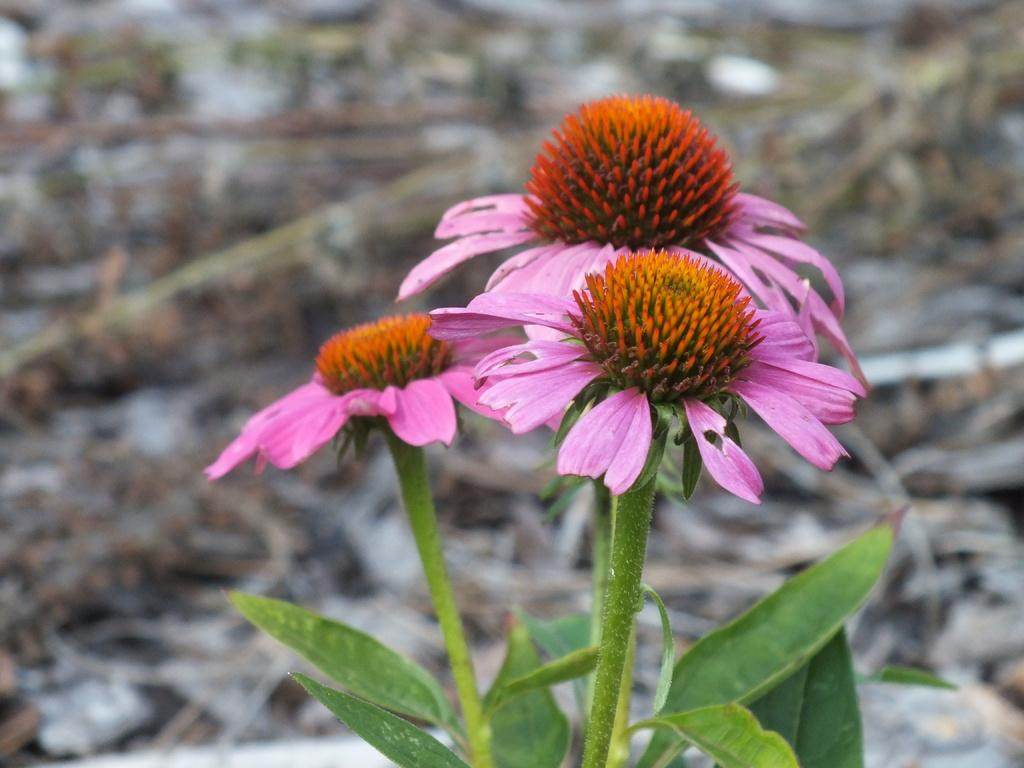What types of plants can be seen in the foreground of the image? There are flowers, leaves, and stems in the foreground of the image. Can you describe the background of the image? The background of the image is blurred. What type of question is being asked in the image? There is no question being asked in the image; it features flowers, leaves, and stems in the foreground and a blurred background. Can you see any trains or houses in the image? No, there are no trains or houses visible in the image. 